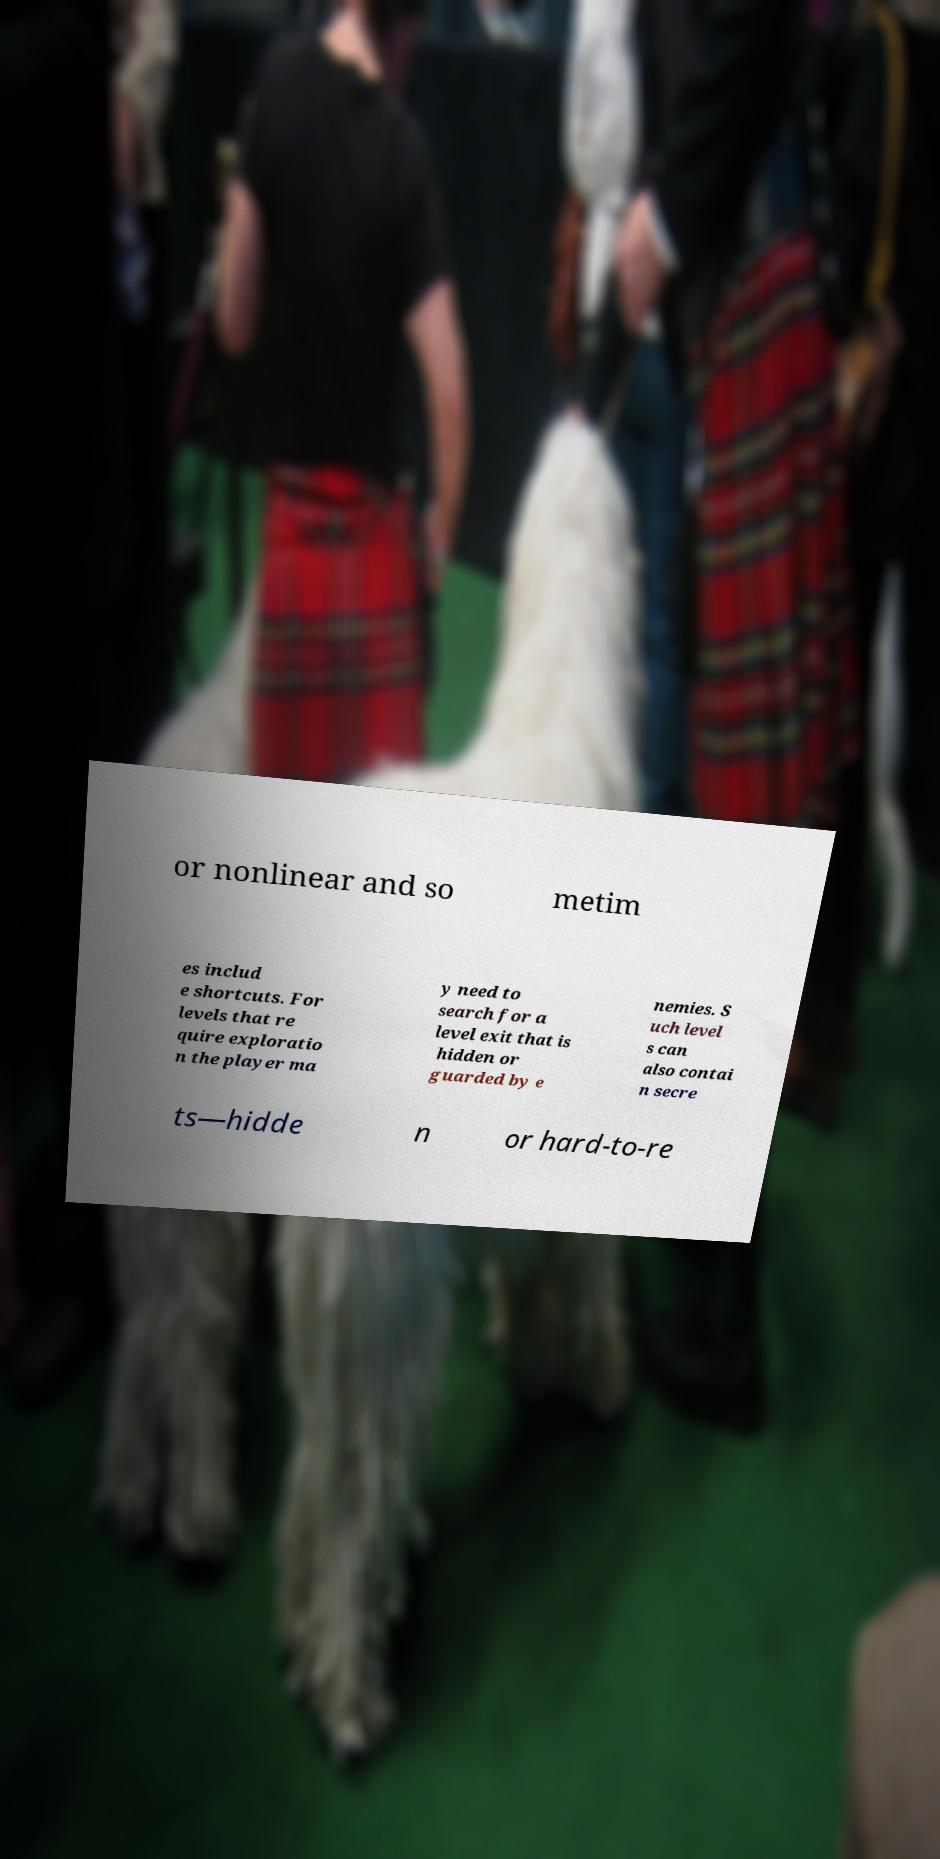Can you accurately transcribe the text from the provided image for me? or nonlinear and so metim es includ e shortcuts. For levels that re quire exploratio n the player ma y need to search for a level exit that is hidden or guarded by e nemies. S uch level s can also contai n secre ts—hidde n or hard-to-re 